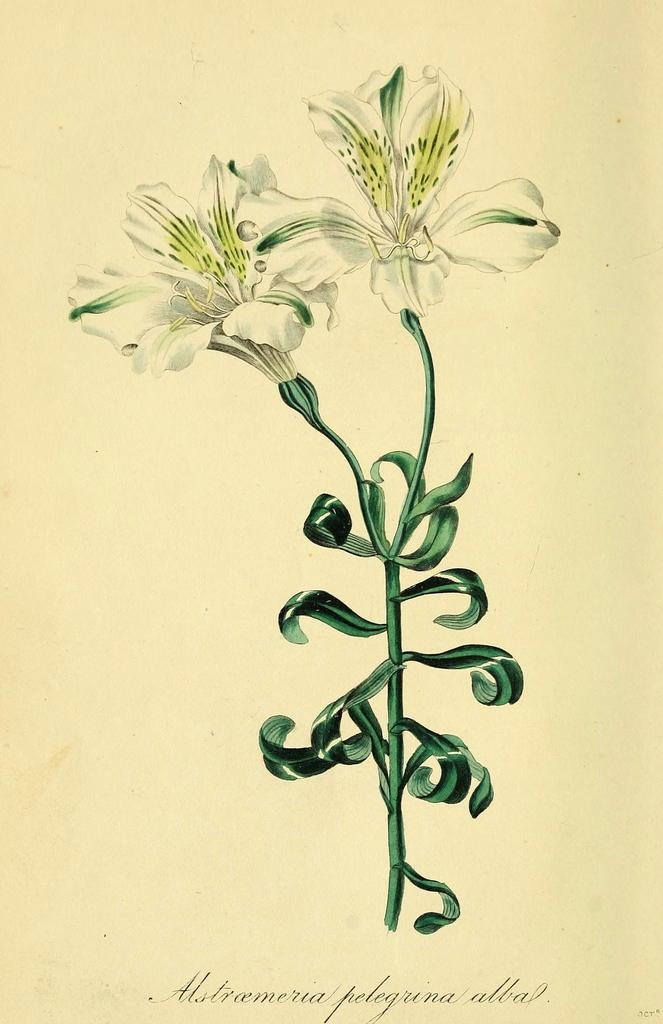What type of flowers are depicted in the painting in the image? The painting in the image depicts white color flowers. Can you describe any additional features of the painting? There is a watermark on the bottom of the image. What type of pest can be seen crawling on the flowers in the image? There are no pests visible in the image; the painting depicts white color flowers without any insects or pests. 